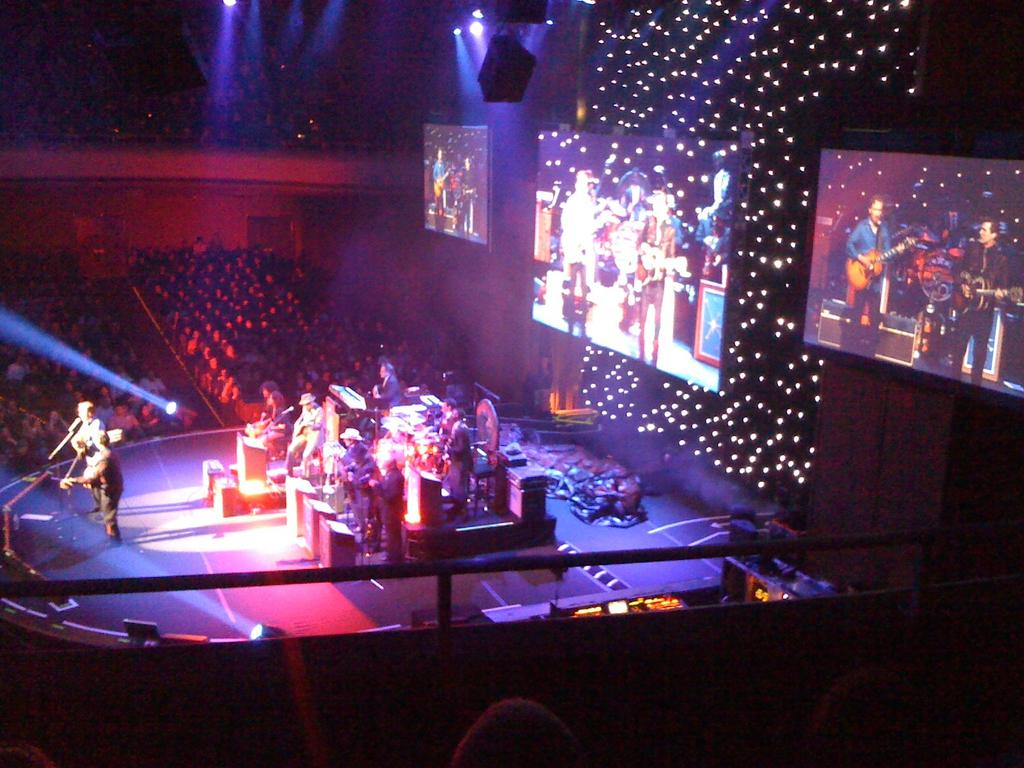What are the people in the image doing? The people in the image are playing musical instruments on a stage. How many people can be seen in the image? There are many people visible in the image. What additional features can be seen in the image? There are screens and lights visible in the image. How many women are visible in the image? There is no mention of women in the image, so it is not possible to answer that question. 